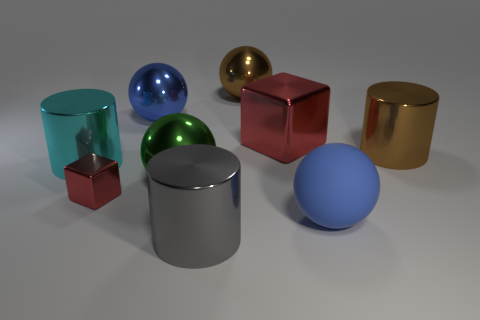Subtract all cylinders. How many objects are left? 6 Subtract all large matte spheres. Subtract all rubber objects. How many objects are left? 7 Add 1 big brown metallic things. How many big brown metallic things are left? 3 Add 6 green metallic balls. How many green metallic balls exist? 7 Subtract 1 brown cylinders. How many objects are left? 8 